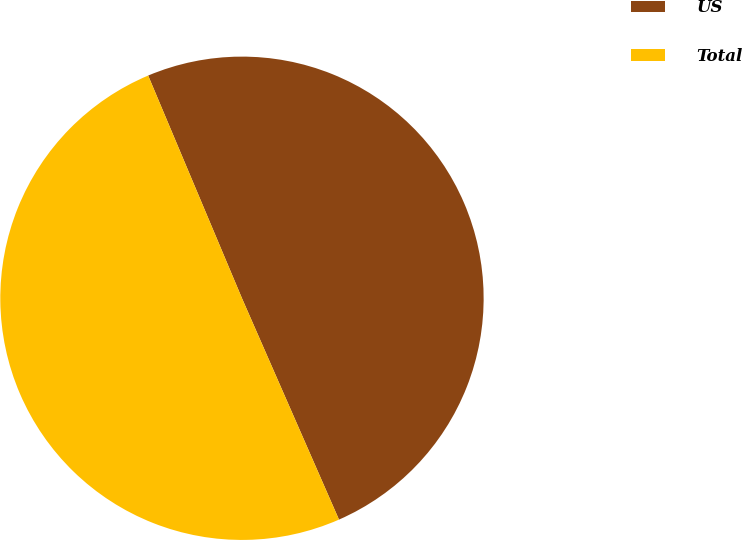Convert chart. <chart><loc_0><loc_0><loc_500><loc_500><pie_chart><fcel>US<fcel>Total<nl><fcel>49.77%<fcel>50.23%<nl></chart> 